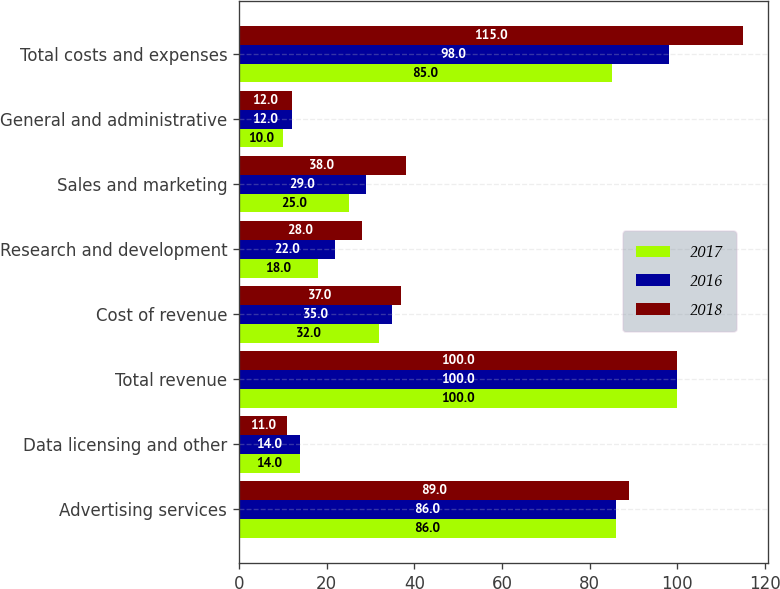Convert chart. <chart><loc_0><loc_0><loc_500><loc_500><stacked_bar_chart><ecel><fcel>Advertising services<fcel>Data licensing and other<fcel>Total revenue<fcel>Cost of revenue<fcel>Research and development<fcel>Sales and marketing<fcel>General and administrative<fcel>Total costs and expenses<nl><fcel>2017<fcel>86<fcel>14<fcel>100<fcel>32<fcel>18<fcel>25<fcel>10<fcel>85<nl><fcel>2016<fcel>86<fcel>14<fcel>100<fcel>35<fcel>22<fcel>29<fcel>12<fcel>98<nl><fcel>2018<fcel>89<fcel>11<fcel>100<fcel>37<fcel>28<fcel>38<fcel>12<fcel>115<nl></chart> 